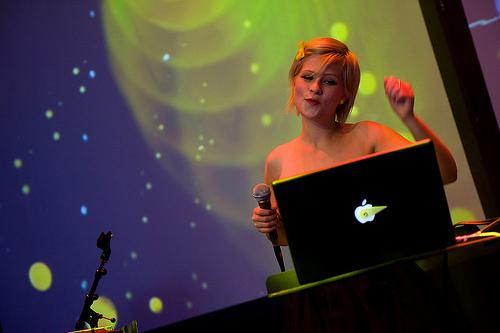Mention a few notable details about the woman's outfit and accessories. The woman has a yellow bow in her hair, a ring on her finger, and reveals her bare shoulders while holding the microphone. Comment on the presence of a specific accessory and how it relates to the woman's overall look. The woman's short blonde hair is adorned with a yellow bow on the side, adding a playful touch to her hairstyle. Briefly explain the scene depicted in the image. A young blonde woman making a presentation with a microphone in her hand, standing in front of a laptop on a table and a blue background with projected lights. Write a sentence mentioning the color of the laptop and the brand logo seen on it. In front of the woman is a black laptop with an Apple symbol prominently displayed on it. Describe the appearance of the background and how it complements the scene. A woman performs against a glittering blue background with green light, projected spots, and bubbles, enhancing the presentation atmosphere. Mention the key aspects of the woman's appearance and the items she's interacting with. The woman has blonde hair, a yellow bow, and red lips, holds a small microphone in her hand, and stands near a laptop and microphone stand. Acknowledge some of the smaller details in the image, such as lighting and stage setup. On the stage is a green light shining near the woman, along with a vertical microphone stand and a black metal microphone stand. Share an overview of the image, highlighting the woman's actions and the surrounding objects. In the image, a woman presents with a microphone near a black laptop on a brown table, standing against a blue wall with multiple round spots and a green light. Using a single sentence, capture the atmosphere and the main action taking place in the image. The woman confidently delivers her presentation, illuminated by colorful lights while holding a microphone and standing by a laptop. Explain what the woman is doing and in which context. A pretty blonde woman is holding a microphone to deliver a presentation, with a laptop on a table in front of her and a shining blue background. 